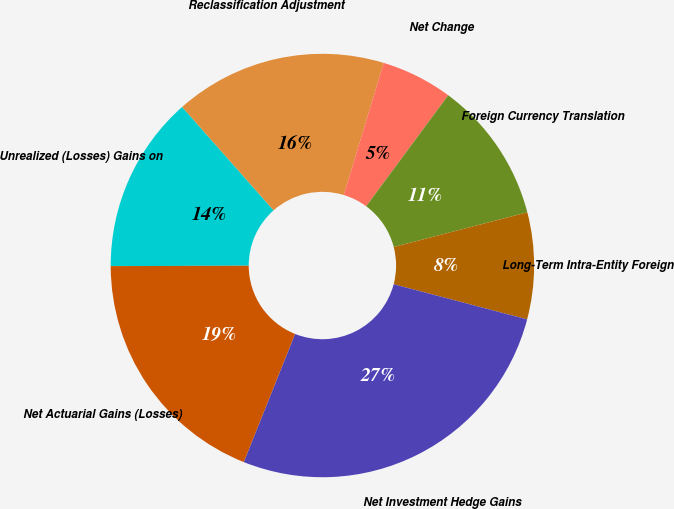Convert chart. <chart><loc_0><loc_0><loc_500><loc_500><pie_chart><fcel>Unrealized (Losses) Gains on<fcel>Reclassification Adjustment<fcel>Net Change<fcel>Foreign Currency Translation<fcel>Long-Term Intra-Entity Foreign<fcel>Net Investment Hedge Gains<fcel>Net Actuarial Gains (Losses)<nl><fcel>13.52%<fcel>16.21%<fcel>5.45%<fcel>10.83%<fcel>8.14%<fcel>26.97%<fcel>18.9%<nl></chart> 